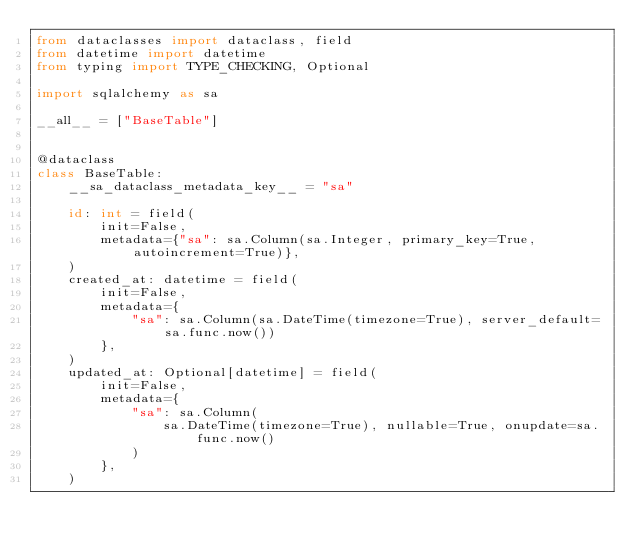<code> <loc_0><loc_0><loc_500><loc_500><_Python_>from dataclasses import dataclass, field
from datetime import datetime
from typing import TYPE_CHECKING, Optional

import sqlalchemy as sa

__all__ = ["BaseTable"]


@dataclass
class BaseTable:
    __sa_dataclass_metadata_key__ = "sa"

    id: int = field(
        init=False,
        metadata={"sa": sa.Column(sa.Integer, primary_key=True, autoincrement=True)},
    )
    created_at: datetime = field(
        init=False,
        metadata={
            "sa": sa.Column(sa.DateTime(timezone=True), server_default=sa.func.now())
        },
    )
    updated_at: Optional[datetime] = field(
        init=False,
        metadata={
            "sa": sa.Column(
                sa.DateTime(timezone=True), nullable=True, onupdate=sa.func.now()
            )
        },
    )
</code> 